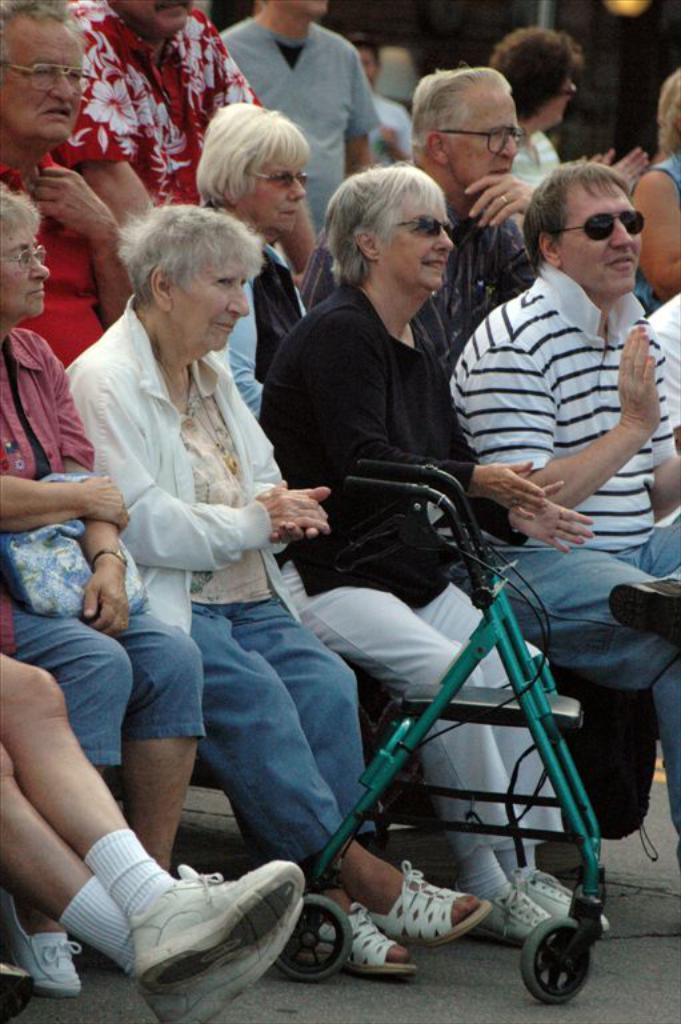In one or two sentences, can you explain what this image depicts? In this image we can see some people sitting and some of them are standing and there is a vehicle on the road. 